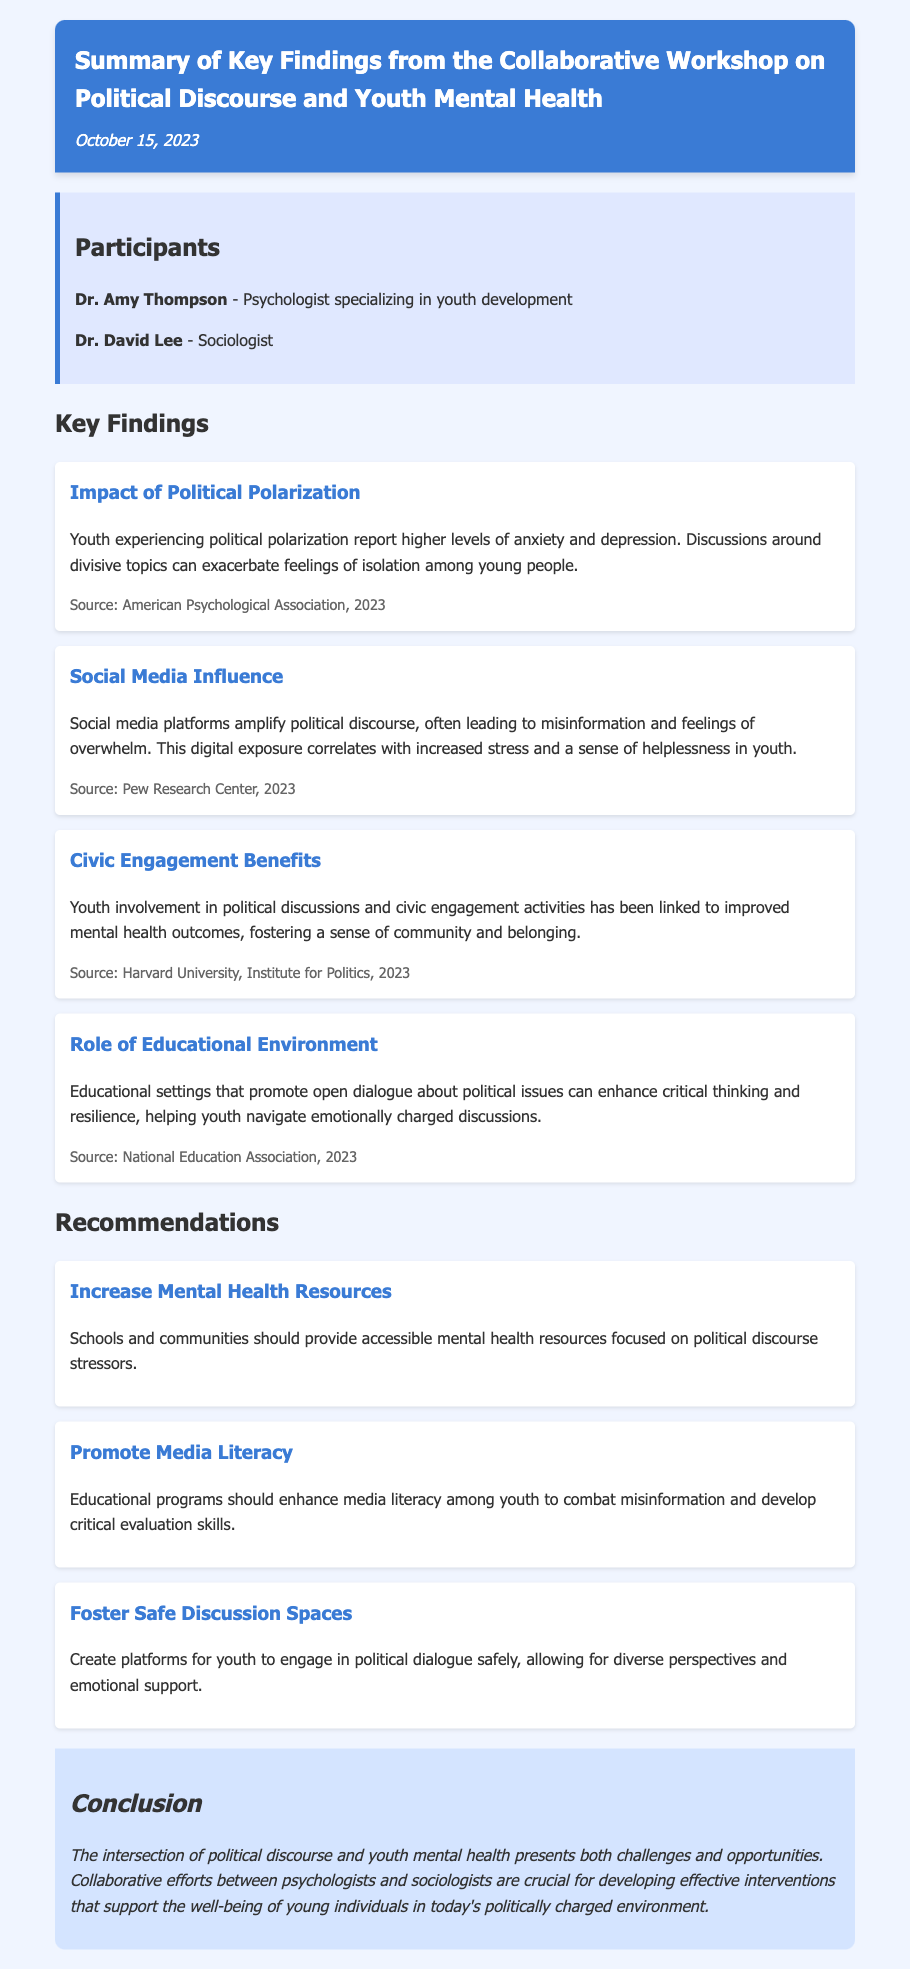What is the date of the workshop? The date listed in the document is when the findings were summarized.
Answer: October 15, 2023 Who are the participants in the workshop? The document explicitly mentions the names and titles of the participants involved in the workshop.
Answer: Dr. Amy Thompson and Dr. David Lee What is one impact of political polarization on youth? The finding describes how political polarization affects youth mental health, specifically mentioning anxiety and depression.
Answer: Anxiety and depression Which source discusses social media influence? The document cites a specific source regarding the impact of social media on youth mental health.
Answer: Pew Research Center, 2023 What benefit does civic engagement provide to youth? The key finding links youth involvement in civic activities to specific positive mental health outcomes.
Answer: Improved mental health outcomes What should schools provide according to the recommendations? The recommendations section emphasizes specific types of resources that schools should focus on, particularly related to mental health.
Answer: Accessible mental health resources What is the main conclusion drawn from the workshop? The conclusion summarizes the overall insights and emphasizes the significance of collaboration between the fields discussed.
Answer: Collaborative efforts between psychologists and sociologists What does the recommendation about media literacy suggest? The document outlines a specific educational focus aimed at youth in relation to media consumption.
Answer: Enhance media literacy among youth 